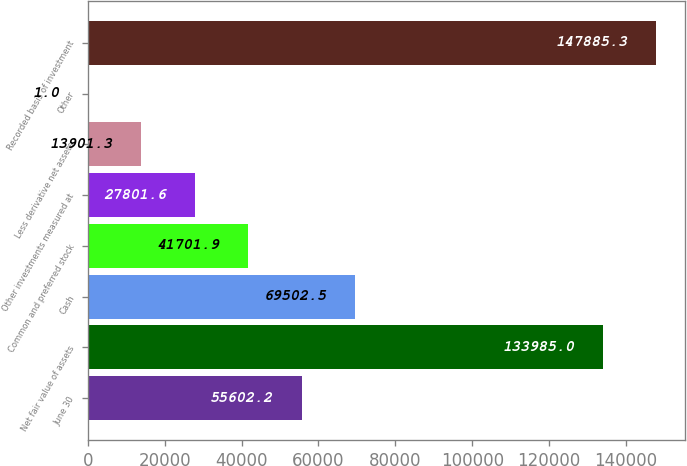<chart> <loc_0><loc_0><loc_500><loc_500><bar_chart><fcel>June 30<fcel>Net fair value of assets<fcel>Cash<fcel>Common and preferred stock<fcel>Other investments measured at<fcel>Less derivative net assets<fcel>Other<fcel>Recorded basis of investment<nl><fcel>55602.2<fcel>133985<fcel>69502.5<fcel>41701.9<fcel>27801.6<fcel>13901.3<fcel>1<fcel>147885<nl></chart> 